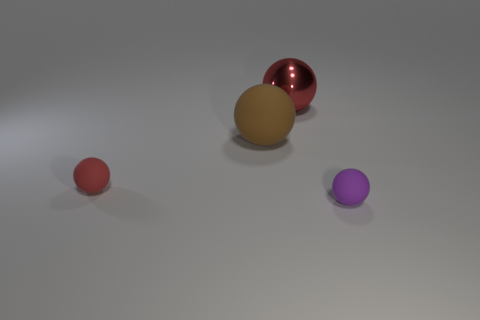Subtract all cyan balls. Subtract all cyan cylinders. How many balls are left? 4 Add 3 large shiny objects. How many objects exist? 7 Subtract 0 red cubes. How many objects are left? 4 Subtract all large brown matte things. Subtract all purple balls. How many objects are left? 2 Add 4 large matte spheres. How many large matte spheres are left? 5 Add 4 green metallic cylinders. How many green metallic cylinders exist? 4 